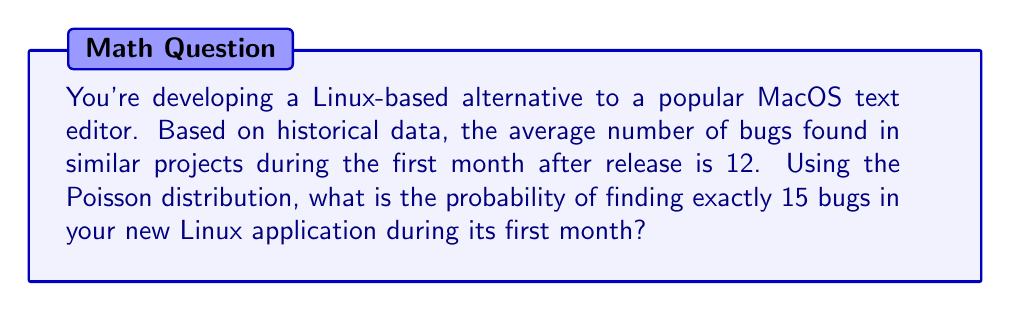Teach me how to tackle this problem. To solve this problem, we'll use the Poisson distribution formula:

$$P(X = k) = \frac{e^{-\lambda} \lambda^k}{k!}$$

Where:
- $\lambda$ is the average number of events (in this case, bugs) in the given time period
- $k$ is the number of events we're interested in
- $e$ is Euler's number (approximately 2.71828)

Given:
- $\lambda = 12$ (average number of bugs)
- $k = 15$ (exactly 15 bugs)

Let's substitute these values into the formula:

$$P(X = 15) = \frac{e^{-12} 12^{15}}{15!}$$

Now, let's calculate step by step:

1. Calculate $e^{-12}$:
   $e^{-12} \approx 6.14421 \times 10^{-6}$

2. Calculate $12^{15}$:
   $12^{15} = 1.28916 \times 10^{16}$

3. Calculate $15!$:
   $15! = 1,307,674,368,000$

4. Substitute these values into the formula:
   $$P(X = 15) = \frac{(6.14421 \times 10^{-6})(1.28916 \times 10^{16})}{1,307,674,368,000}$$

5. Simplify:
   $$P(X = 15) \approx 0.0605$$

6. Convert to a percentage:
   $0.0605 \times 100\% = 6.05\%$

Therefore, the probability of finding exactly 15 bugs in the new Linux application during its first month is approximately 6.05%.
Answer: 6.05% 